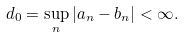<formula> <loc_0><loc_0><loc_500><loc_500>d _ { 0 } = \sup _ { n } | a _ { n } - b _ { n } | < \infty .</formula> 